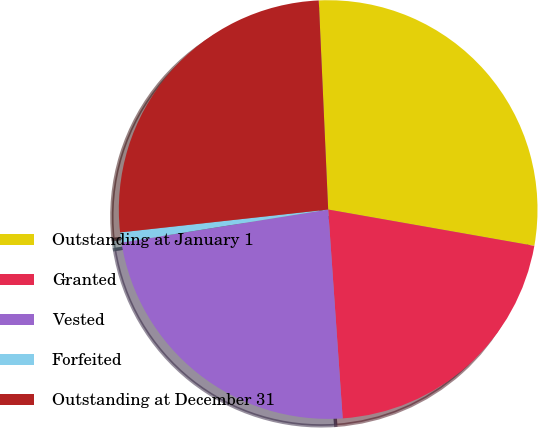Convert chart. <chart><loc_0><loc_0><loc_500><loc_500><pie_chart><fcel>Outstanding at January 1<fcel>Granted<fcel>Vested<fcel>Forfeited<fcel>Outstanding at December 31<nl><fcel>28.49%<fcel>21.12%<fcel>23.58%<fcel>0.78%<fcel>26.03%<nl></chart> 